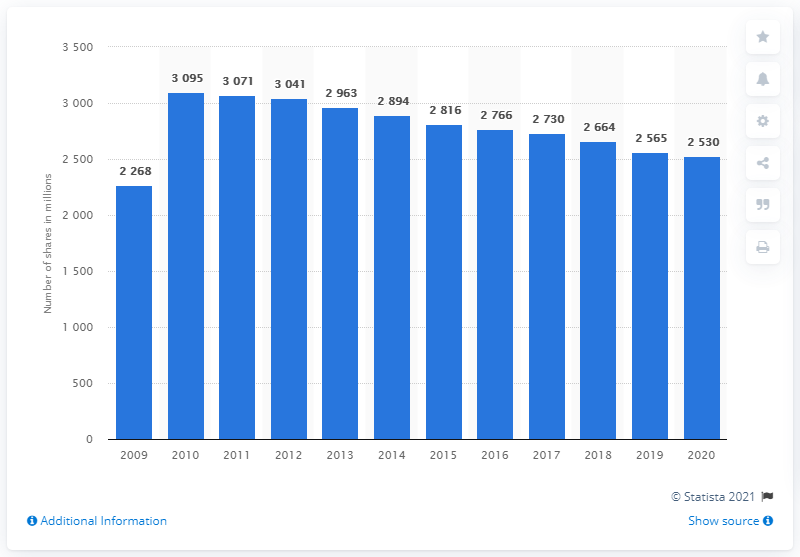Mention a couple of crucial points in this snapshot. In 2020, the average number of shares outstanding for Merck & Co. was approximately 25,300. 